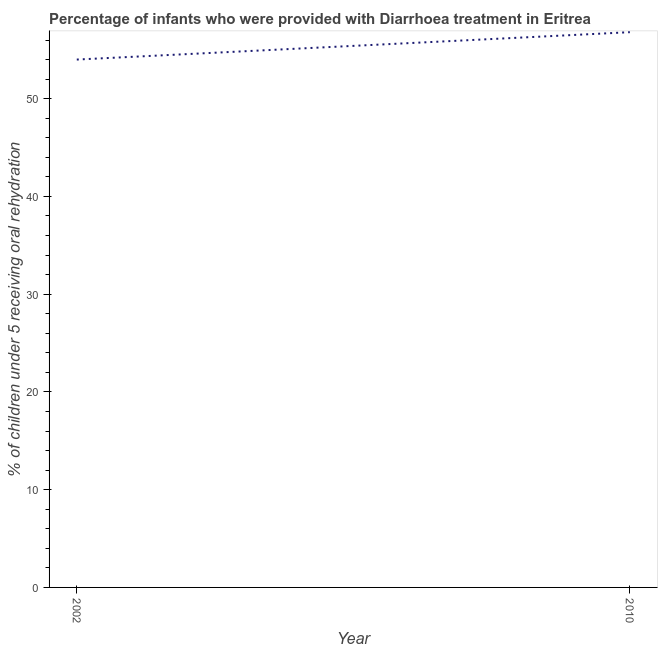What is the percentage of children who were provided with treatment diarrhoea in 2002?
Keep it short and to the point. 54. Across all years, what is the maximum percentage of children who were provided with treatment diarrhoea?
Offer a terse response. 56.8. In which year was the percentage of children who were provided with treatment diarrhoea maximum?
Give a very brief answer. 2010. What is the sum of the percentage of children who were provided with treatment diarrhoea?
Give a very brief answer. 110.8. What is the difference between the percentage of children who were provided with treatment diarrhoea in 2002 and 2010?
Offer a terse response. -2.8. What is the average percentage of children who were provided with treatment diarrhoea per year?
Keep it short and to the point. 55.4. What is the median percentage of children who were provided with treatment diarrhoea?
Provide a succinct answer. 55.4. What is the ratio of the percentage of children who were provided with treatment diarrhoea in 2002 to that in 2010?
Ensure brevity in your answer.  0.95. Is the percentage of children who were provided with treatment diarrhoea in 2002 less than that in 2010?
Give a very brief answer. Yes. In how many years, is the percentage of children who were provided with treatment diarrhoea greater than the average percentage of children who were provided with treatment diarrhoea taken over all years?
Keep it short and to the point. 1. Does the percentage of children who were provided with treatment diarrhoea monotonically increase over the years?
Your response must be concise. Yes. How many lines are there?
Give a very brief answer. 1. How many years are there in the graph?
Offer a very short reply. 2. Are the values on the major ticks of Y-axis written in scientific E-notation?
Give a very brief answer. No. Does the graph contain grids?
Provide a short and direct response. No. What is the title of the graph?
Your answer should be very brief. Percentage of infants who were provided with Diarrhoea treatment in Eritrea. What is the label or title of the Y-axis?
Keep it short and to the point. % of children under 5 receiving oral rehydration. What is the % of children under 5 receiving oral rehydration in 2010?
Ensure brevity in your answer.  56.8. What is the ratio of the % of children under 5 receiving oral rehydration in 2002 to that in 2010?
Ensure brevity in your answer.  0.95. 